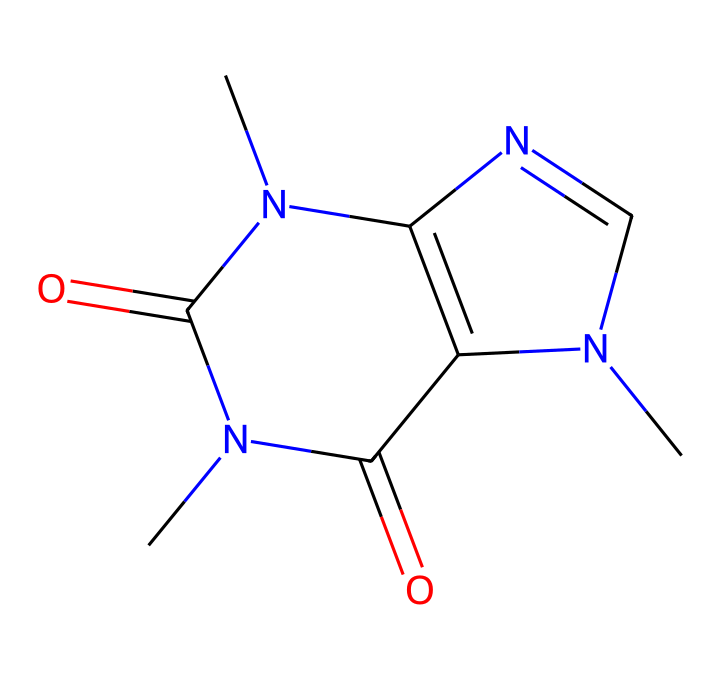What is the molecular formula of caffeine? By examining the chemical structure and counting the different types of atoms, we identify 8 carbon (C) atoms, 10 hydrogen (H) atoms, 4 nitrogen (N) atoms, and 2 oxygen (O) atoms. Therefore, the molecular formula is C8H10N4O2.
Answer: C8H10N4O2 How many nitrogen atoms are present in caffeine? The structure reveals the presence of four nitrogen atoms (N), as we can count them directly in the structure.
Answer: four What is the primary functional group present in caffeine? Analyzing the structure, we can identify the presence of carbonyl groups (C=O) within the structure, which is characteristic of amides and ketones in this compound. Therefore, the primary functional group is carbonyl.
Answer: carbonyl What type of compound is caffeine classified as? Caffeine has a nitrogenous base structure and exhibits properties commonly associated with alkaloids. Since it contains nitrogen and affects the nervous system, it is classified as an alkaloid.
Answer: alkaloid What is the significance of the number of rings in caffeine's structure? The structure of caffeine contains two rings, which are characteristic of purine-like compounds. This bicyclic nature contributes to its pharmacological effects and solubility properties. The two rings indicate it is a bicyclic compound, often linked to stimulant activity.
Answer: bicyclic compound 